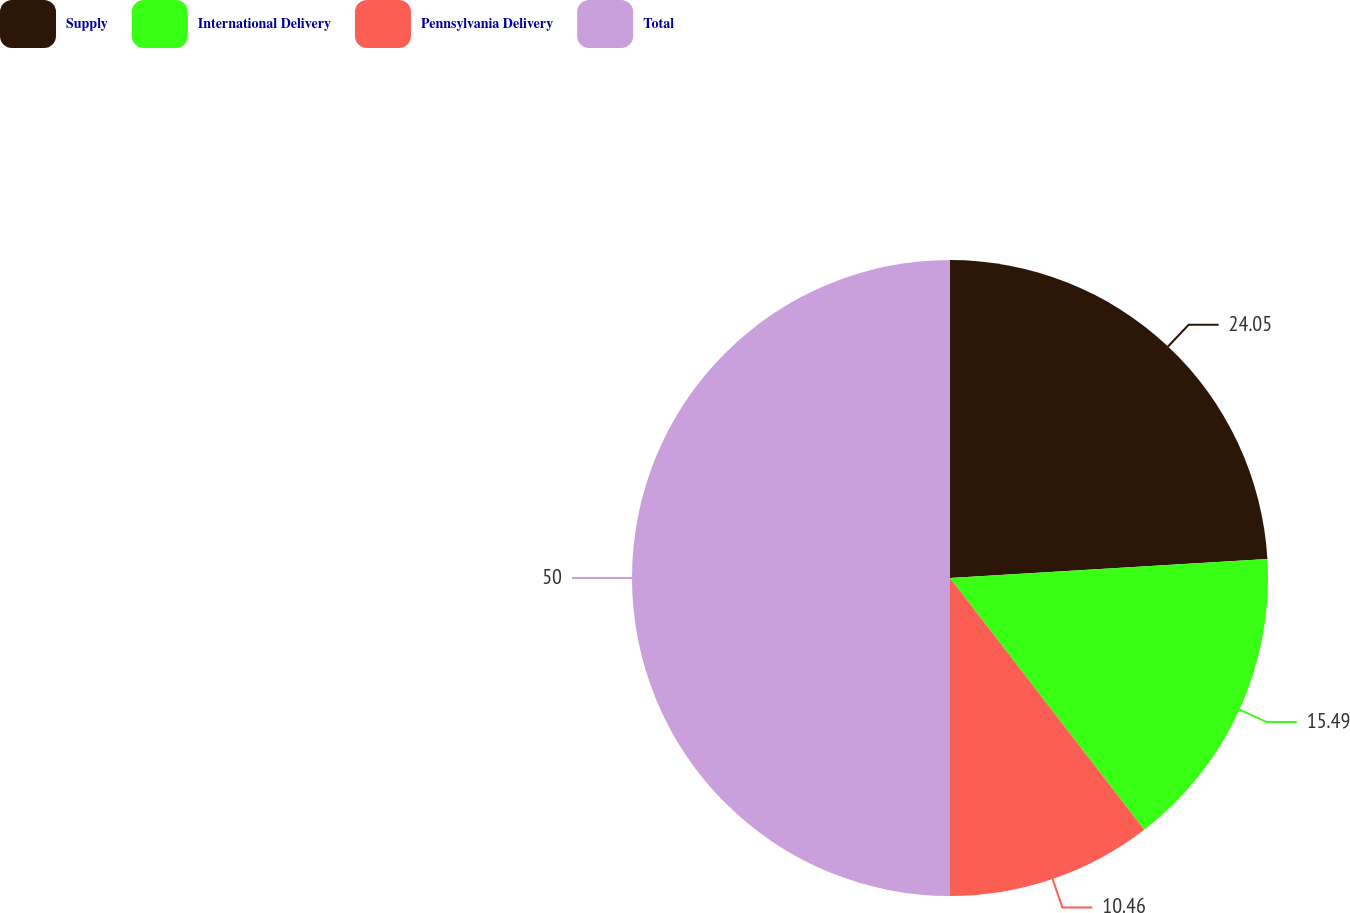Convert chart to OTSL. <chart><loc_0><loc_0><loc_500><loc_500><pie_chart><fcel>Supply<fcel>International Delivery<fcel>Pennsylvania Delivery<fcel>Total<nl><fcel>24.05%<fcel>15.49%<fcel>10.46%<fcel>50.0%<nl></chart> 